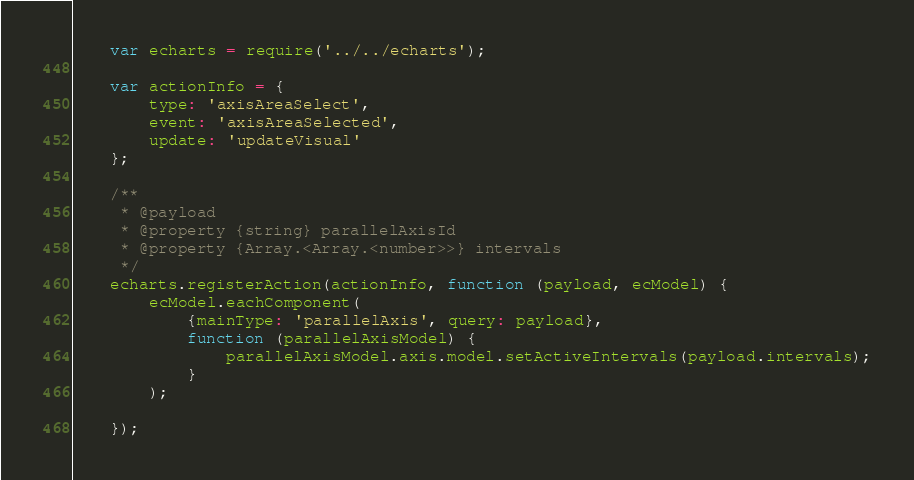Convert code to text. <code><loc_0><loc_0><loc_500><loc_500><_JavaScript_>

    var echarts = require('../../echarts');

    var actionInfo = {
        type: 'axisAreaSelect',
        event: 'axisAreaSelected',
        update: 'updateVisual'
    };

    /**
     * @payload
     * @property {string} parallelAxisId
     * @property {Array.<Array.<number>>} intervals
     */
    echarts.registerAction(actionInfo, function (payload, ecModel) {
        ecModel.eachComponent(
            {mainType: 'parallelAxis', query: payload},
            function (parallelAxisModel) {
                parallelAxisModel.axis.model.setActiveIntervals(payload.intervals);
            }
        );

    });
</code> 